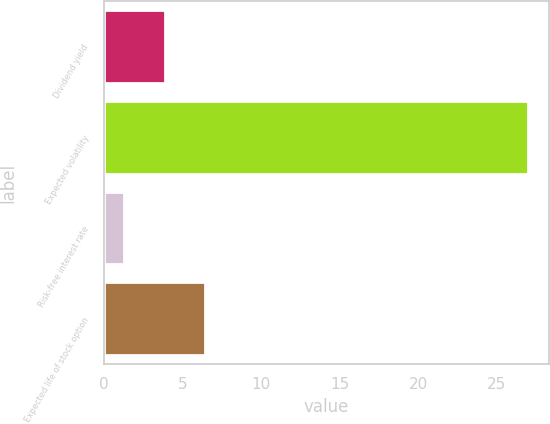Convert chart. <chart><loc_0><loc_0><loc_500><loc_500><bar_chart><fcel>Dividend yield<fcel>Expected volatility<fcel>Risk-free interest rate<fcel>Expected life of stock option<nl><fcel>3.87<fcel>27<fcel>1.3<fcel>6.44<nl></chart> 